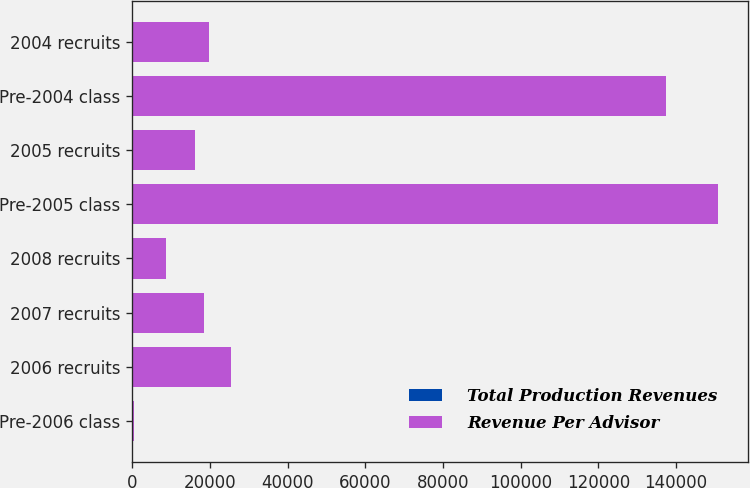Convert chart to OTSL. <chart><loc_0><loc_0><loc_500><loc_500><stacked_bar_chart><ecel><fcel>Pre-2006 class<fcel>2006 recruits<fcel>2007 recruits<fcel>2008 recruits<fcel>Pre-2005 class<fcel>2005 recruits<fcel>Pre-2004 class<fcel>2004 recruits<nl><fcel>Total Production Revenues<fcel>264<fcel>173<fcel>201<fcel>120<fcel>257<fcel>145<fcel>250<fcel>157<nl><fcel>Revenue Per Advisor<fcel>264<fcel>25145<fcel>18302<fcel>8585<fcel>150612<fcel>16040<fcel>137212<fcel>19579<nl></chart> 